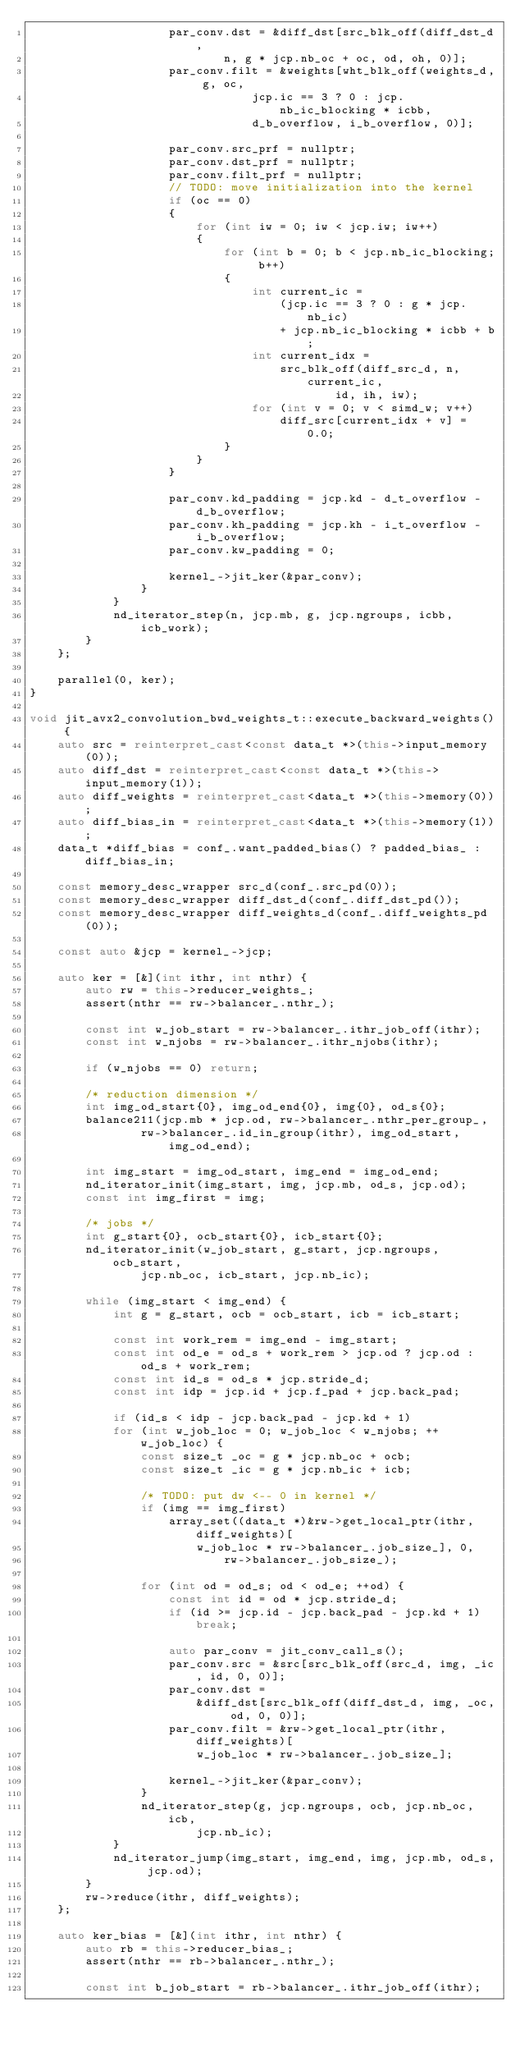<code> <loc_0><loc_0><loc_500><loc_500><_C++_>                    par_conv.dst = &diff_dst[src_blk_off(diff_dst_d,
                            n, g * jcp.nb_oc + oc, od, oh, 0)];
                    par_conv.filt = &weights[wht_blk_off(weights_d, g, oc,
                                jcp.ic == 3 ? 0 : jcp.nb_ic_blocking * icbb,
                                d_b_overflow, i_b_overflow, 0)];

                    par_conv.src_prf = nullptr;
                    par_conv.dst_prf = nullptr;
                    par_conv.filt_prf = nullptr;
                    // TODO: move initialization into the kernel
                    if (oc == 0)
                    {
                        for (int iw = 0; iw < jcp.iw; iw++)
                        {
                            for (int b = 0; b < jcp.nb_ic_blocking; b++)
                            {
                                int current_ic =
                                    (jcp.ic == 3 ? 0 : g * jcp.nb_ic)
                                    + jcp.nb_ic_blocking * icbb + b;
                                int current_idx =
                                    src_blk_off(diff_src_d, n, current_ic,
                                            id, ih, iw);
                                for (int v = 0; v < simd_w; v++)
                                    diff_src[current_idx + v] = 0.0;
                            }
                        }
                    }

                    par_conv.kd_padding = jcp.kd - d_t_overflow - d_b_overflow;
                    par_conv.kh_padding = jcp.kh - i_t_overflow - i_b_overflow;
                    par_conv.kw_padding = 0;

                    kernel_->jit_ker(&par_conv);
                }
            }
            nd_iterator_step(n, jcp.mb, g, jcp.ngroups, icbb, icb_work);
        }
    };

    parallel(0, ker);
}

void jit_avx2_convolution_bwd_weights_t::execute_backward_weights() {
    auto src = reinterpret_cast<const data_t *>(this->input_memory(0));
    auto diff_dst = reinterpret_cast<const data_t *>(this->input_memory(1));
    auto diff_weights = reinterpret_cast<data_t *>(this->memory(0));
    auto diff_bias_in = reinterpret_cast<data_t *>(this->memory(1));
    data_t *diff_bias = conf_.want_padded_bias() ? padded_bias_ : diff_bias_in;

    const memory_desc_wrapper src_d(conf_.src_pd(0));
    const memory_desc_wrapper diff_dst_d(conf_.diff_dst_pd());
    const memory_desc_wrapper diff_weights_d(conf_.diff_weights_pd(0));

    const auto &jcp = kernel_->jcp;

    auto ker = [&](int ithr, int nthr) {
        auto rw = this->reducer_weights_;
        assert(nthr == rw->balancer_.nthr_);

        const int w_job_start = rw->balancer_.ithr_job_off(ithr);
        const int w_njobs = rw->balancer_.ithr_njobs(ithr);

        if (w_njobs == 0) return;

        /* reduction dimension */
        int img_od_start{0}, img_od_end{0}, img{0}, od_s{0};
        balance211(jcp.mb * jcp.od, rw->balancer_.nthr_per_group_,
                rw->balancer_.id_in_group(ithr), img_od_start, img_od_end);

        int img_start = img_od_start, img_end = img_od_end;
        nd_iterator_init(img_start, img, jcp.mb, od_s, jcp.od);
        const int img_first = img;

        /* jobs */
        int g_start{0}, ocb_start{0}, icb_start{0};
        nd_iterator_init(w_job_start, g_start, jcp.ngroups, ocb_start,
                jcp.nb_oc, icb_start, jcp.nb_ic);

        while (img_start < img_end) {
            int g = g_start, ocb = ocb_start, icb = icb_start;

            const int work_rem = img_end - img_start;
            const int od_e = od_s + work_rem > jcp.od ? jcp.od : od_s + work_rem;
            const int id_s = od_s * jcp.stride_d;
            const int idp = jcp.id + jcp.f_pad + jcp.back_pad;

            if (id_s < idp - jcp.back_pad - jcp.kd + 1)
            for (int w_job_loc = 0; w_job_loc < w_njobs; ++w_job_loc) {
                const size_t _oc = g * jcp.nb_oc + ocb;
                const size_t _ic = g * jcp.nb_ic + icb;

                /* TODO: put dw <-- 0 in kernel */
                if (img == img_first)
                    array_set((data_t *)&rw->get_local_ptr(ithr, diff_weights)[
                        w_job_loc * rw->balancer_.job_size_], 0,
                            rw->balancer_.job_size_);

                for (int od = od_s; od < od_e; ++od) {
                    const int id = od * jcp.stride_d;
                    if (id >= jcp.id - jcp.back_pad - jcp.kd + 1) break;

                    auto par_conv = jit_conv_call_s();
                    par_conv.src = &src[src_blk_off(src_d, img, _ic, id, 0, 0)];
                    par_conv.dst =
                        &diff_dst[src_blk_off(diff_dst_d, img, _oc, od, 0, 0)];
                    par_conv.filt = &rw->get_local_ptr(ithr, diff_weights)[
                        w_job_loc * rw->balancer_.job_size_];

                    kernel_->jit_ker(&par_conv);
                }
                nd_iterator_step(g, jcp.ngroups, ocb, jcp.nb_oc, icb,
                        jcp.nb_ic);
            }
            nd_iterator_jump(img_start, img_end, img, jcp.mb, od_s, jcp.od);
        }
        rw->reduce(ithr, diff_weights);
    };

    auto ker_bias = [&](int ithr, int nthr) {
        auto rb = this->reducer_bias_;
        assert(nthr == rb->balancer_.nthr_);

        const int b_job_start = rb->balancer_.ithr_job_off(ithr);</code> 